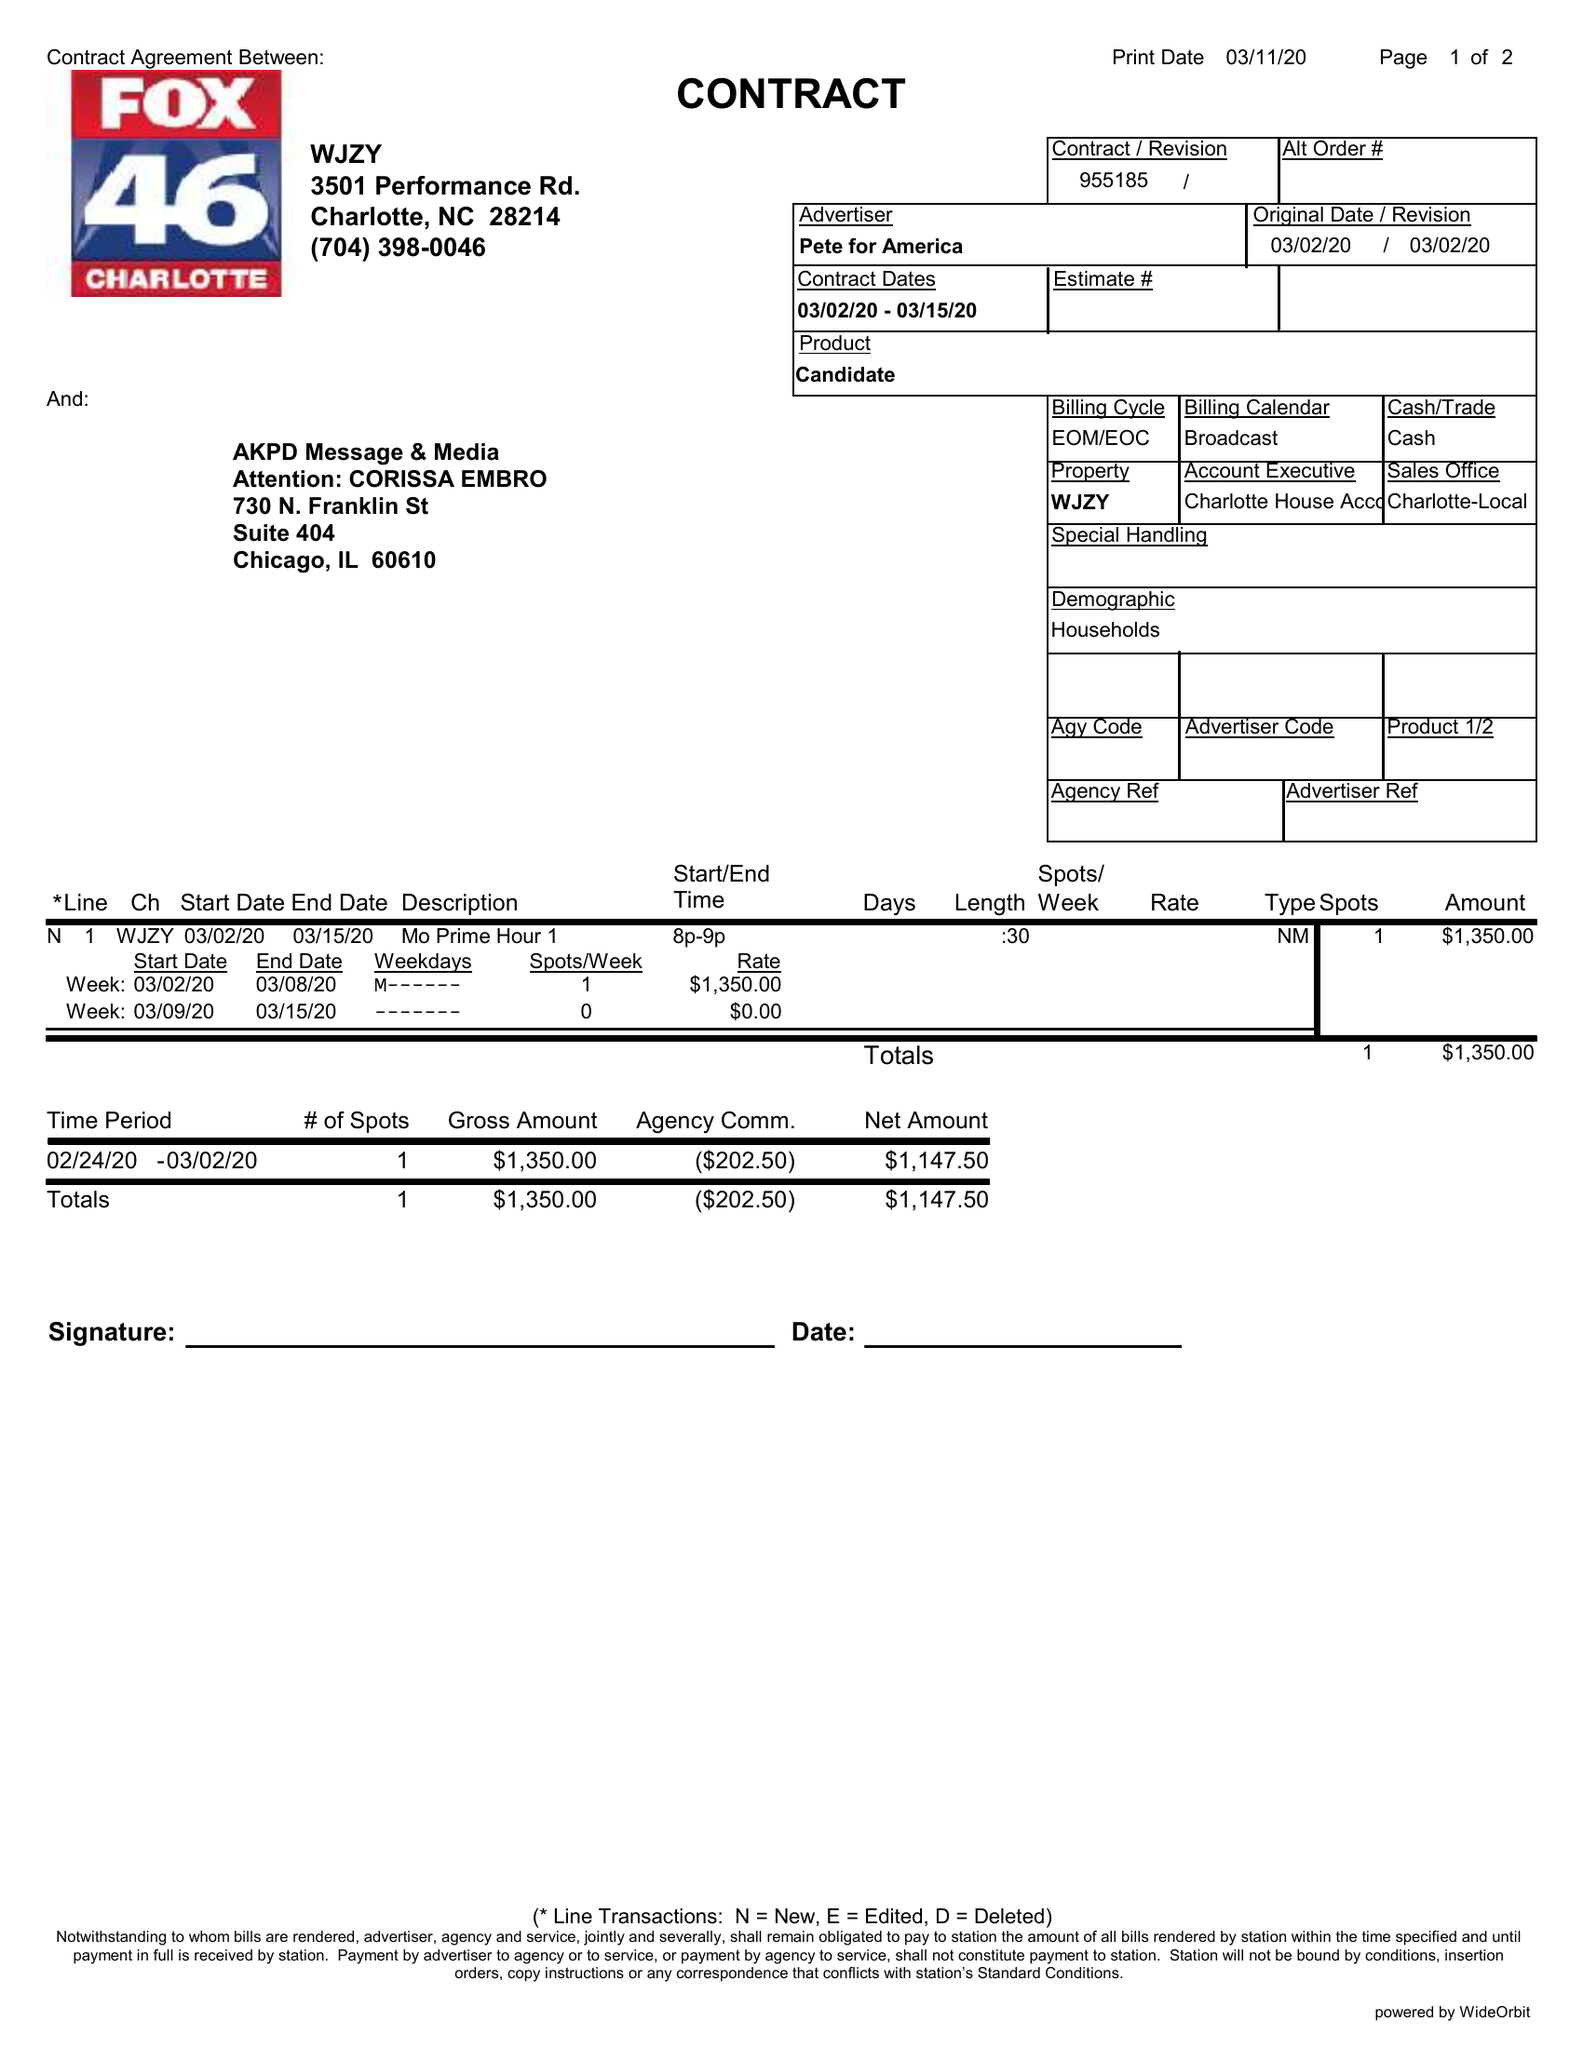What is the value for the flight_to?
Answer the question using a single word or phrase. 03/15/20 